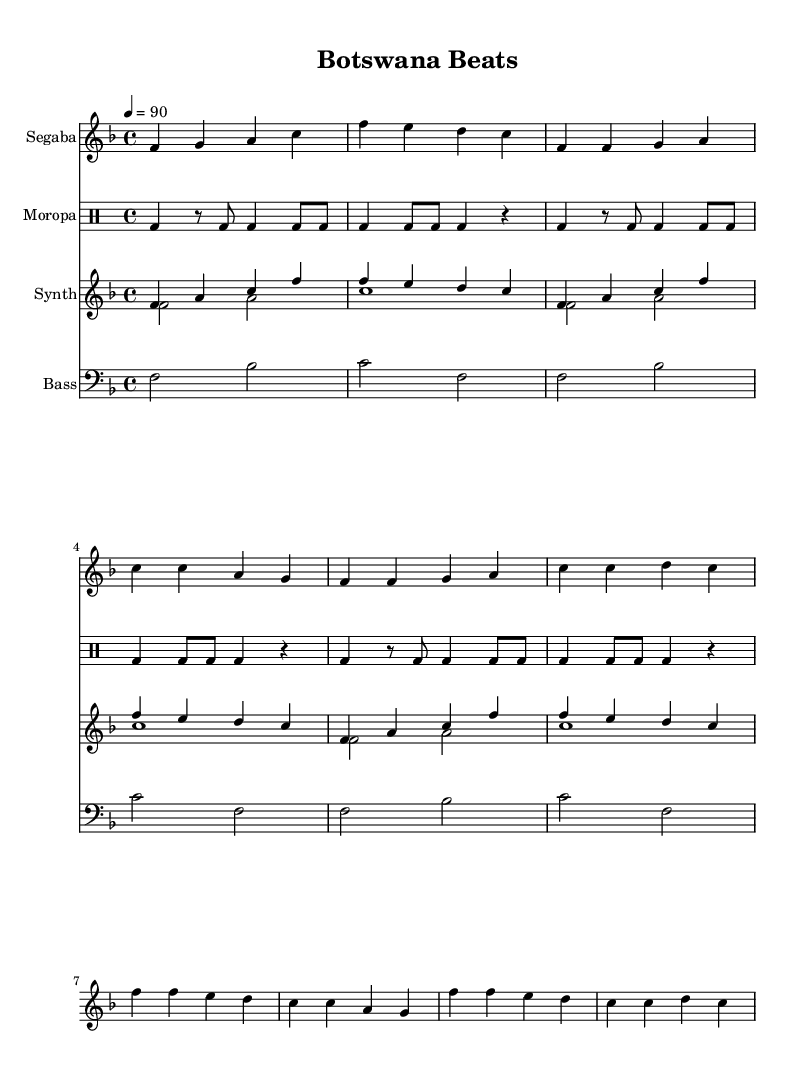What is the key signature of this music? The key signature is F major, which has one flat (B flat). This can be determined by looking at the key signature indicated at the beginning of the score, where it shows a flat symbol on the B line of the staff.
Answer: F major What is the time signature of this music? The time signature is 4/4, which indicates that there are four beats in each measure and the quarter note receives one beat. This can be observed at the beginning of the score where the time signature is displayed.
Answer: 4/4 What is the tempo marking for this piece? The tempo marking is 90 beats per minute, which is indicated at the beginning of the score with the notation "4 = 90". This specifies the speed at which the music should be played.
Answer: 90 How many measures are in the Segaba section? The Segaba section consists of eight measures, which can be counted by looking at the vertical bar lines that separate each measure throughout this section of the music.
Answer: 8 What instruments are featured in this arrangement? The instruments featured are Segaba, Moropa, Synth, and Bass. This information can be found in the score's instrument names placed above each staff.
Answer: Segaba, Moropa, Synth, Bass How many different voices are used in the Synth part? There are two different voices used in the Synth part, designated as "voiceOne" and "voiceTwo". This can be identified by looking at the specific annotations that label these voices in the score.
Answer: 2 What musical style does this composition represent? This composition represents Rap fusion incorporating traditional Tswana music and contemporary beats, as denoted in the context of the questions and the arrangement style observed in the score.
Answer: Rap fusion 